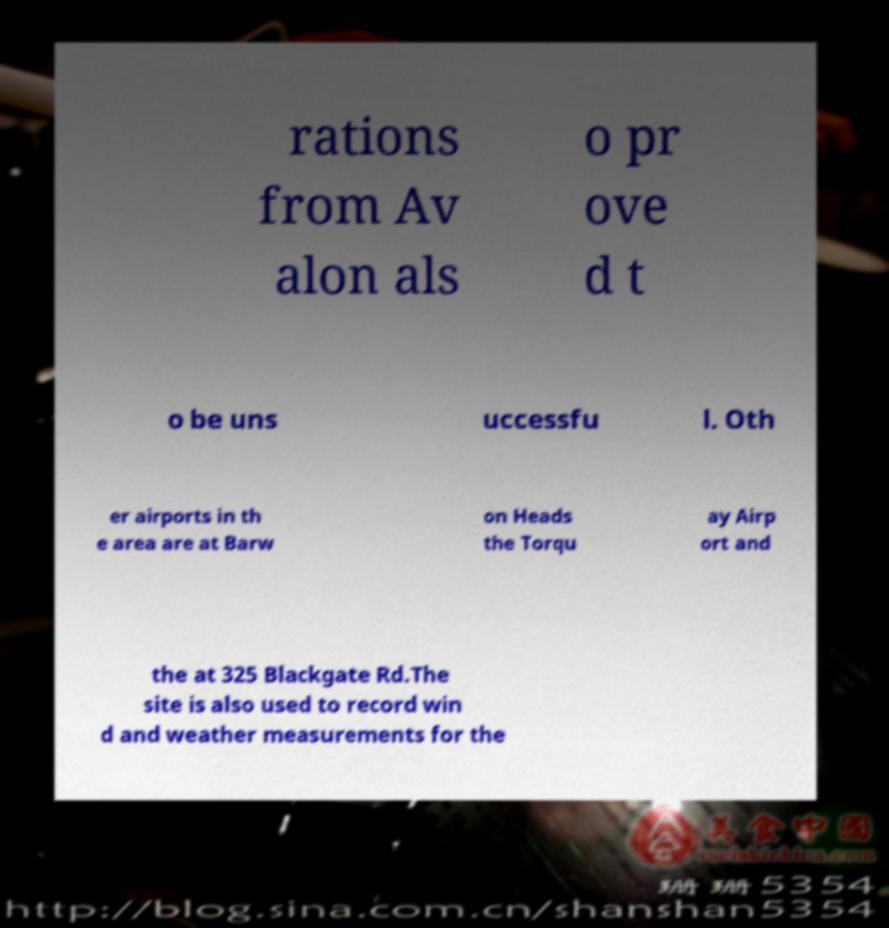There's text embedded in this image that I need extracted. Can you transcribe it verbatim? rations from Av alon als o pr ove d t o be uns uccessfu l. Oth er airports in th e area are at Barw on Heads the Torqu ay Airp ort and the at 325 Blackgate Rd.The site is also used to record win d and weather measurements for the 